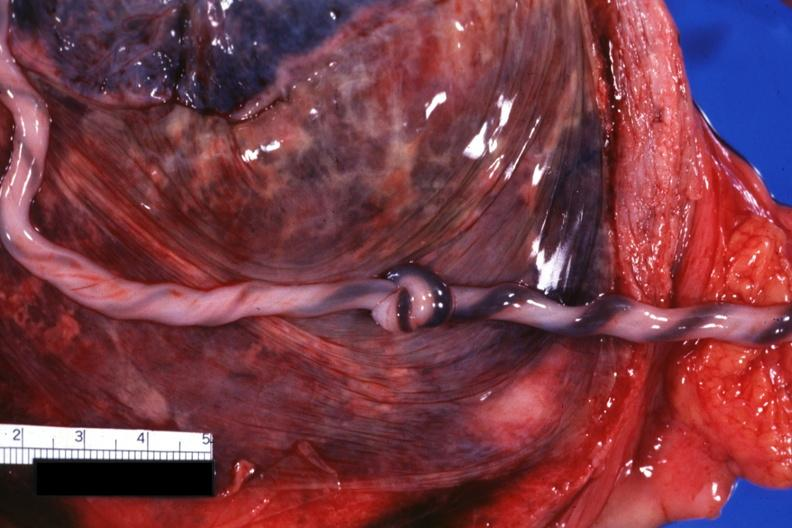where does this part belong to?
Answer the question using a single word or phrase. Female reproductive system 